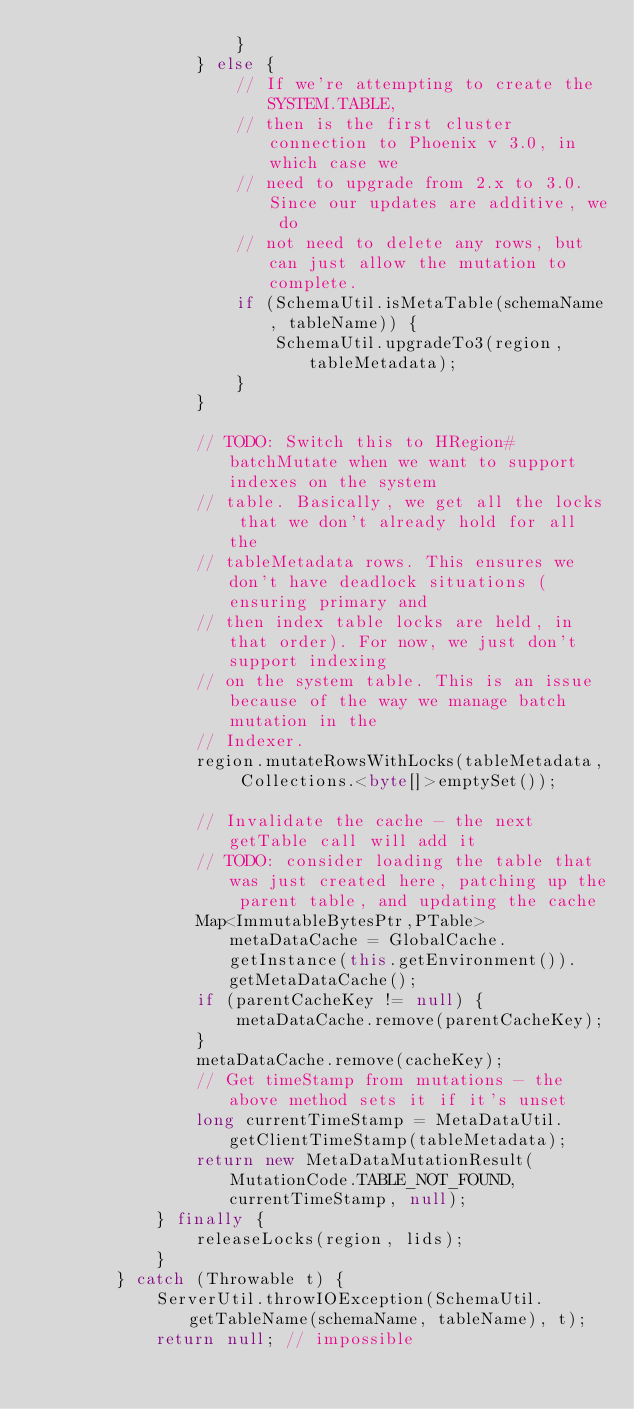Convert code to text. <code><loc_0><loc_0><loc_500><loc_500><_Java_>                    }
                } else {
                    // If we're attempting to create the SYSTEM.TABLE,
                    // then is the first cluster connection to Phoenix v 3.0, in which case we
                    // need to upgrade from 2.x to 3.0. Since our updates are additive, we do
                    // not need to delete any rows, but can just allow the mutation to complete.
                    if (SchemaUtil.isMetaTable(schemaName, tableName)) {
                        SchemaUtil.upgradeTo3(region, tableMetadata);
                    }
                }
                
                // TODO: Switch this to HRegion#batchMutate when we want to support indexes on the system
                // table. Basically, we get all the locks that we don't already hold for all the
                // tableMetadata rows. This ensures we don't have deadlock situations (ensuring primary and
                // then index table locks are held, in that order). For now, we just don't support indexing
                // on the system table. This is an issue because of the way we manage batch mutation in the
                // Indexer.
                region.mutateRowsWithLocks(tableMetadata, Collections.<byte[]>emptySet());
                
                // Invalidate the cache - the next getTable call will add it
                // TODO: consider loading the table that was just created here, patching up the parent table, and updating the cache
                Map<ImmutableBytesPtr,PTable> metaDataCache = GlobalCache.getInstance(this.getEnvironment()).getMetaDataCache();
                if (parentCacheKey != null) {
                    metaDataCache.remove(parentCacheKey);
                }
                metaDataCache.remove(cacheKey);
                // Get timeStamp from mutations - the above method sets it if it's unset
                long currentTimeStamp = MetaDataUtil.getClientTimeStamp(tableMetadata);
                return new MetaDataMutationResult(MutationCode.TABLE_NOT_FOUND, currentTimeStamp, null);
            } finally {
                releaseLocks(region, lids);
            }
        } catch (Throwable t) {
            ServerUtil.throwIOException(SchemaUtil.getTableName(schemaName, tableName), t);
            return null; // impossible</code> 